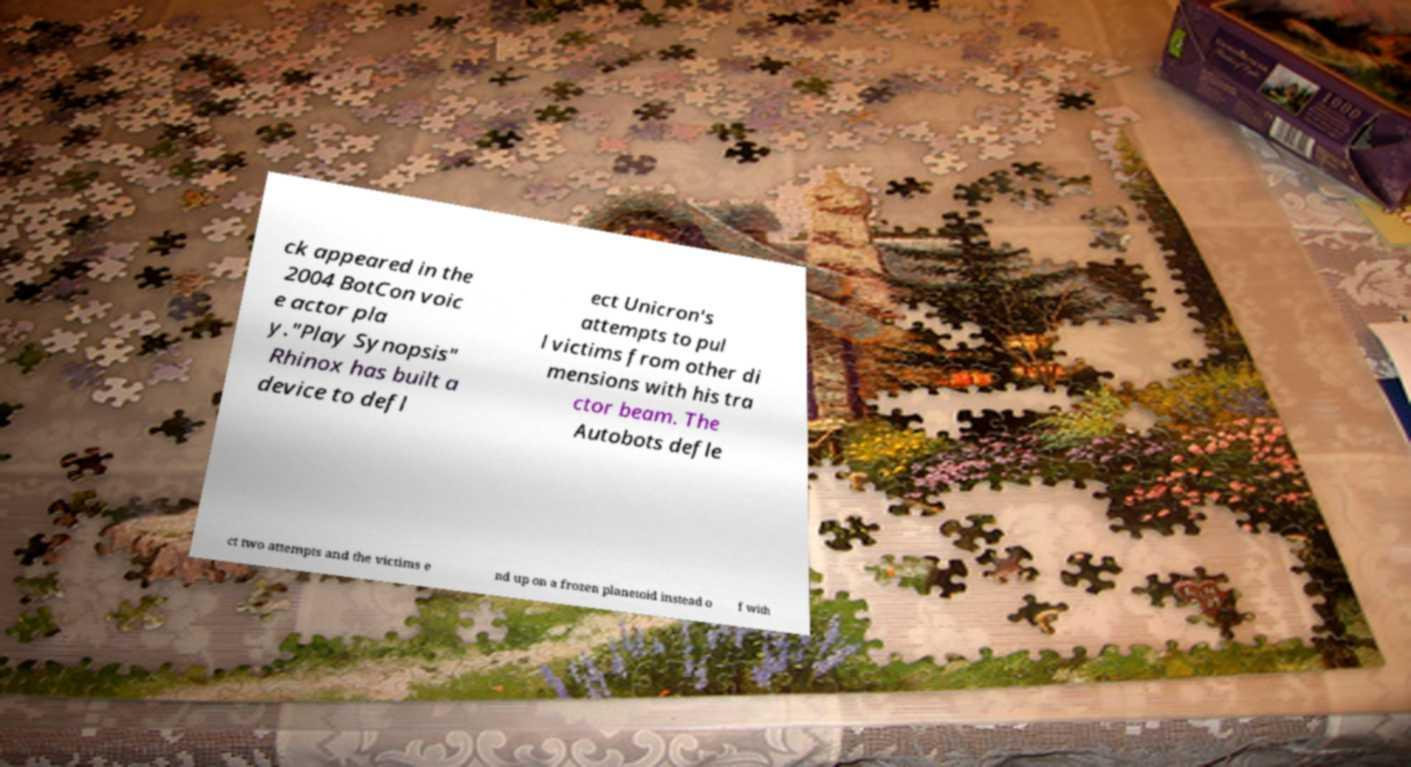For documentation purposes, I need the text within this image transcribed. Could you provide that? ck appeared in the 2004 BotCon voic e actor pla y."Play Synopsis" Rhinox has built a device to defl ect Unicron's attempts to pul l victims from other di mensions with his tra ctor beam. The Autobots defle ct two attempts and the victims e nd up on a frozen planetoid instead o f with 